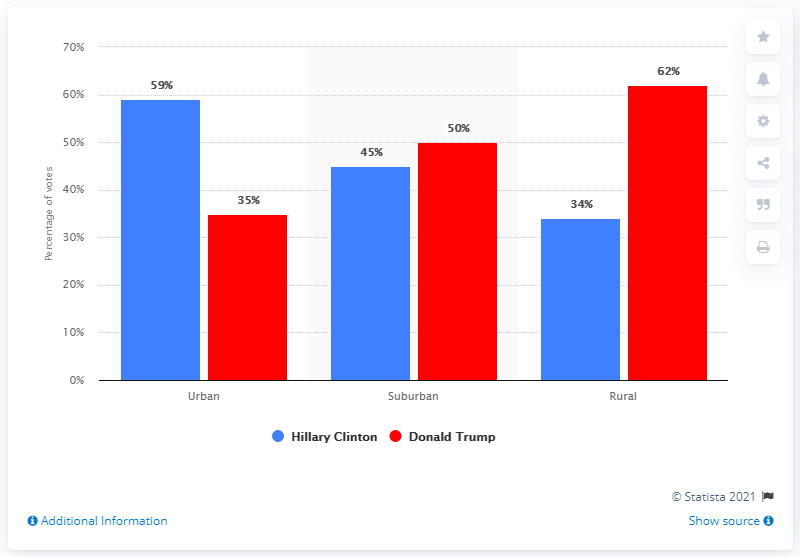Outline some significant characteristics in this image. Donald Trump received the highest percentage of votes in rural areas during the 2016 presidential election. What is the difference in votes between Suburban and Township? 